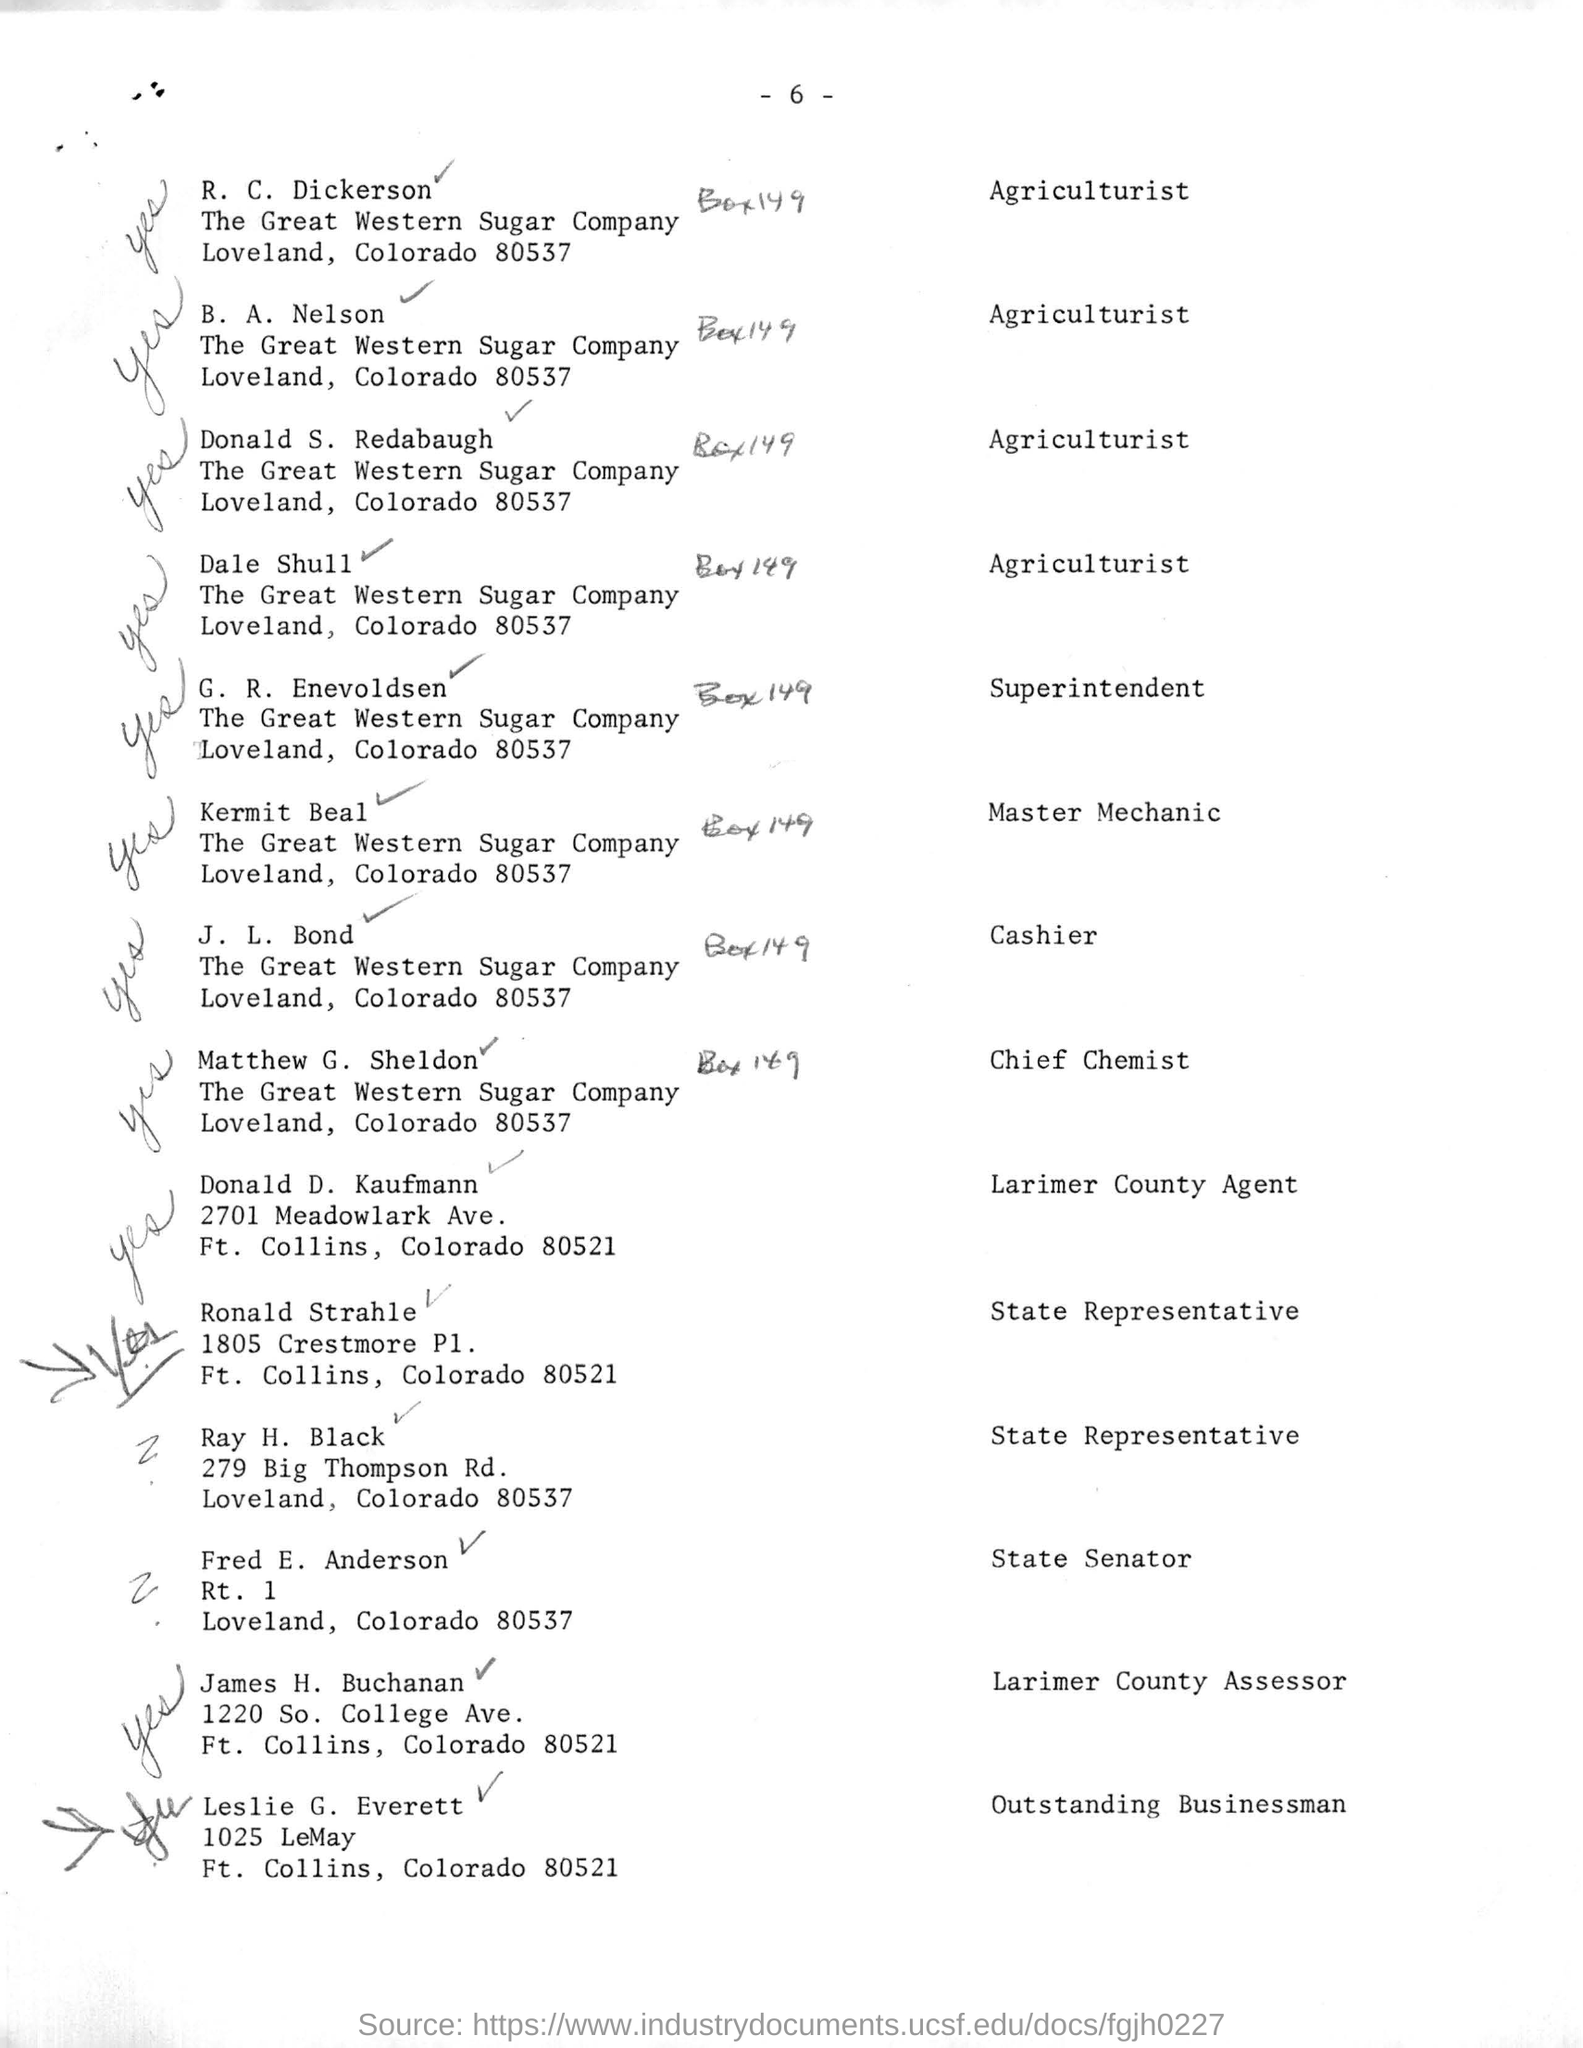Indicate a few pertinent items in this graphic. The person named on the list most recently is Leslie G. Everett. R. C. Dickerson's job title is Agriculturist. The person who was mentioned as the Cashier is J. L. Bond. G. R. Enevoldsen is mentioned as the Superintendent. 